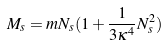<formula> <loc_0><loc_0><loc_500><loc_500>M _ { s } = m N _ { s } ( 1 + \frac { 1 } { 3 \kappa ^ { 4 } } N ^ { 2 } _ { s } )</formula> 